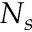<formula> <loc_0><loc_0><loc_500><loc_500>N _ { s }</formula> 